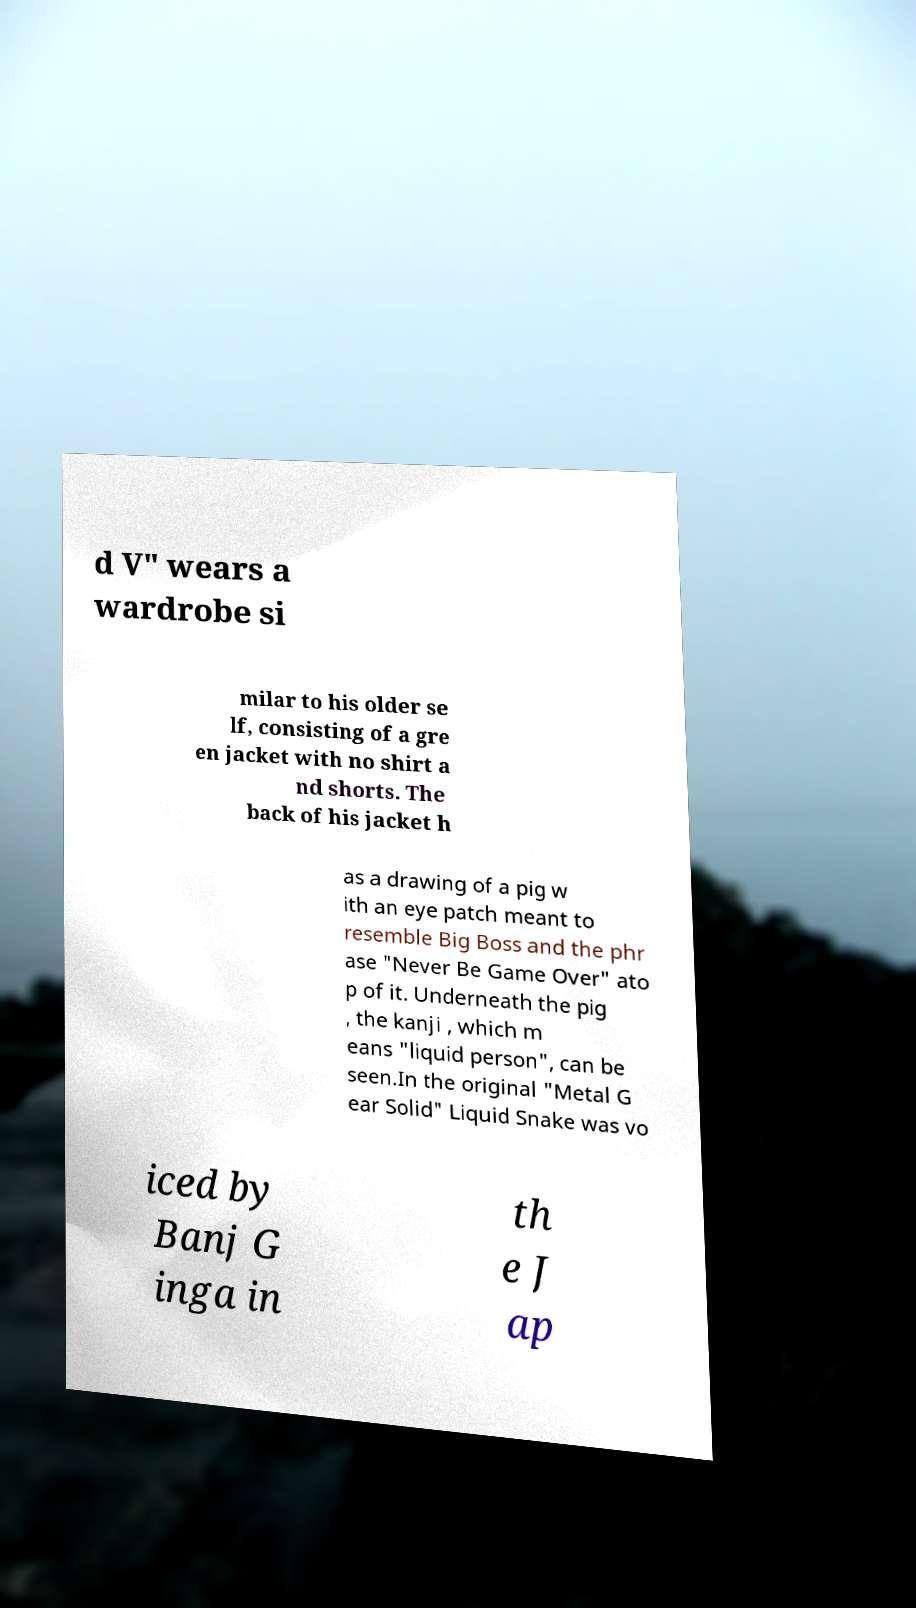I need the written content from this picture converted into text. Can you do that? d V" wears a wardrobe si milar to his older se lf, consisting of a gre en jacket with no shirt a nd shorts. The back of his jacket h as a drawing of a pig w ith an eye patch meant to resemble Big Boss and the phr ase "Never Be Game Over" ato p of it. Underneath the pig , the kanji , which m eans "liquid person", can be seen.In the original "Metal G ear Solid" Liquid Snake was vo iced by Banj G inga in th e J ap 